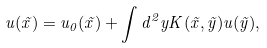<formula> <loc_0><loc_0><loc_500><loc_500>u ( \vec { x } ) = u _ { 0 } ( \vec { x } ) + \int d ^ { 2 } y K ( \vec { x } , \vec { y } ) u ( \vec { y } ) ,</formula> 